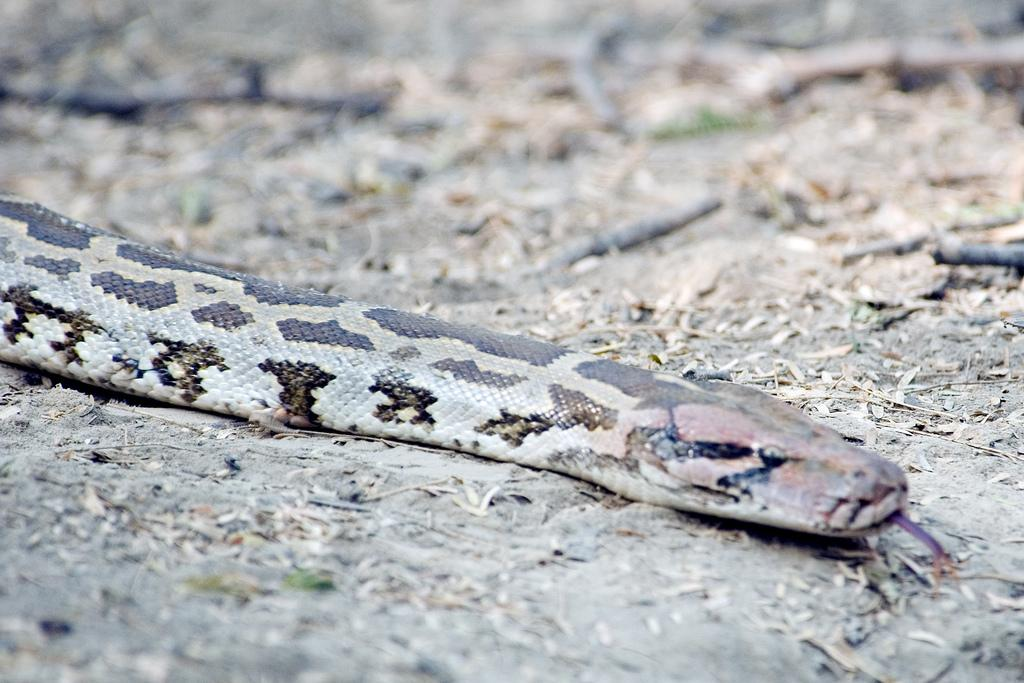What animal can be seen on the ground in the image? There is a snake on the ground in the image. What objects can be seen in the background of the image? There are sticks and leaves in the background of the image. How would you describe the appearance of the background? The background appears blurry. Can you tell me how many bees are buzzing around the snake in the image? There are no bees present in the image; it only features a snake on the ground and objects in the background. Is there a birthday celebration happening in the image? There is no indication of a birthday celebration in the image. 